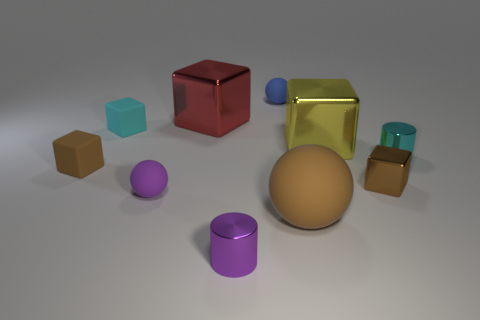Subtract all large red metallic blocks. How many blocks are left? 4 Subtract all red cubes. How many cubes are left? 4 Subtract all gray cubes. Subtract all brown cylinders. How many cubes are left? 5 Subtract all cylinders. How many objects are left? 8 Add 1 small blue rubber balls. How many small blue rubber balls exist? 2 Subtract 0 yellow cylinders. How many objects are left? 10 Subtract all small cyan shiny objects. Subtract all large red cylinders. How many objects are left? 9 Add 7 purple spheres. How many purple spheres are left? 8 